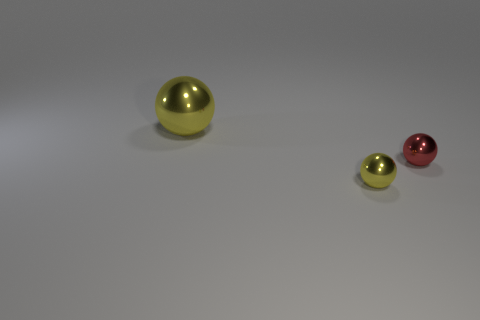Can you tell me the colors of the spheres in the image? Certainly, there are three spheres of different colors. The largest sphere is golden, the medium-sized one is green, and the smallest sphere is red. Do the spheres signify anything or represent a concept? The spheres don't inherently signify anything specific; their interpretation depends on the context in which they are presented. In some cases, different colored spheres could represent different elements, planets, or values if this were part of a larger design or artistic installation. 